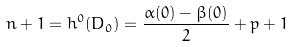Convert formula to latex. <formula><loc_0><loc_0><loc_500><loc_500>n + 1 = h ^ { 0 } ( D _ { 0 } ) = \frac { \alpha ( 0 ) - \beta ( 0 ) } { 2 } + p + 1</formula> 